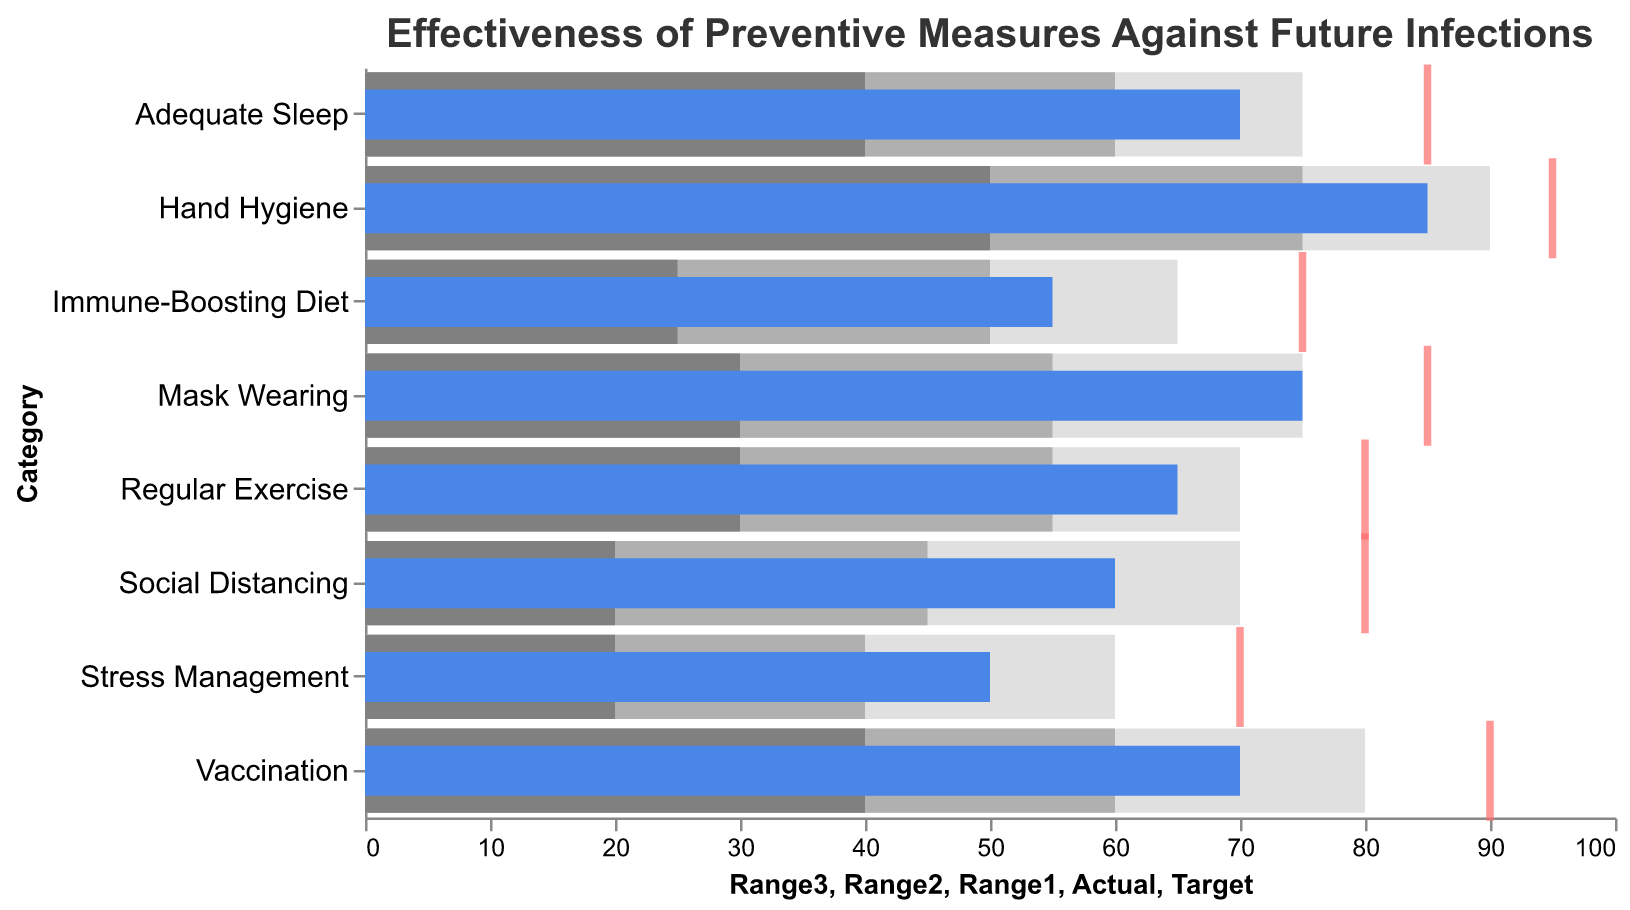What's the title of the plot? The title is often located at the top of the plot. In this case, the title reads: "Effectiveness of Preventive Measures Against Future Infections."
Answer: Effectiveness of Preventive Measures Against Future Infections In which category is the actual effectiveness closest to its target? To answer this, compare the values of 'Actual' and 'Target' for each category and find the smallest difference. "Hand Hygiene" has an 'Actual' of 85 and a 'Target' of 95, making the difference 10. This is the smallest difference among all categories.
Answer: Hand Hygiene What is the actual effectiveness of Adequate Sleep? Locate the "Adequate Sleep" category and read the value under the 'Actual' column, which is represented by a blue bar on the plot. The 'Actual' value for Adequate Sleep is 70.
Answer: 70 Which category has the least actual effectiveness? Compare the 'Actual' values for all categories and find the minimum. "Stress Management" has an actual effectiveness of 50, which is the lowest.
Answer: Stress Management How many categories have an actual effectiveness above 60? Count the number of categories where the 'Actual' value is greater than 60. The categories are Hand Hygiene, Vaccination, Mask Wearing, Regular Exercise, and Adequate Sleep. There are 5 such categories.
Answer: 5 Which preventive measure falls into the worst range (Range1) and has the lowest target? Identify the preventive measures whose actual effectiveness falls within Range1. Among those, the one with the lowest target is "Stress Management" with a target effectiveness value of 70.
Answer: Stress Management What is the color of the marks representing the targets in the plot? Review the plot and identify the color used to draw the tick marks representing the targets. The tick marks are red.
Answer: Red How much higher is the actual effectiveness of Mask Wearing compared to an Immune-Boosting Diet? Subtract the actual effectiveness value of Immune-Boosting Diet from that of Mask Wearing. Mask Wearing has an actual effectiveness of 75, and Immune-Boosting Diet has 55. The difference is 75 - 55 = 20.
Answer: 20 